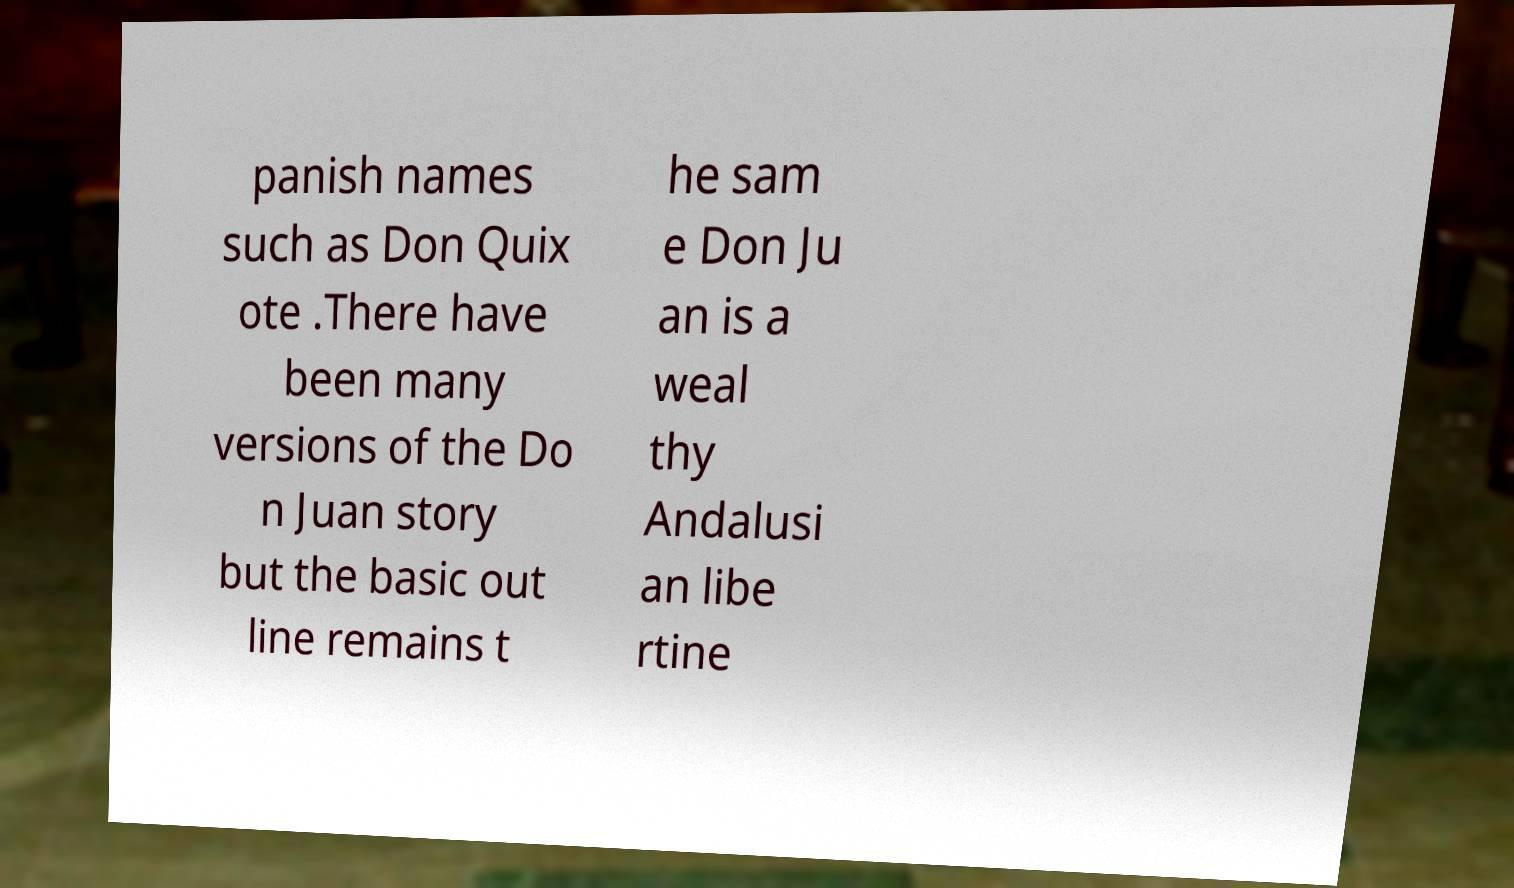Could you extract and type out the text from this image? panish names such as Don Quix ote .There have been many versions of the Do n Juan story but the basic out line remains t he sam e Don Ju an is a weal thy Andalusi an libe rtine 